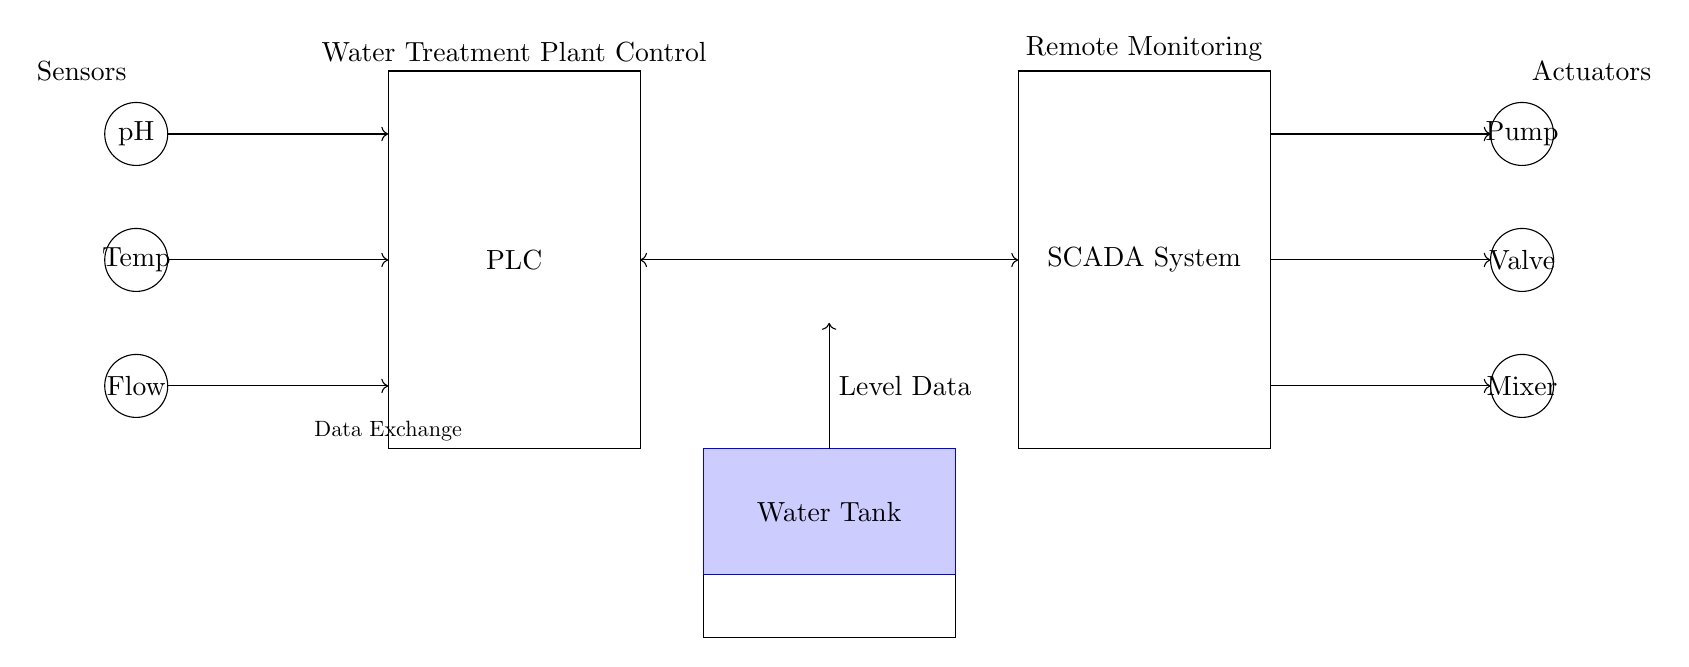What are the main components of the control system? The main components are the PLC, SCADA system, sensors (pH, temperature, flow), and actuators (pump, valve, mixer). These components are visually represented in the circuit diagram.
Answer: PLC, SCADA, Sensors, Actuators Which sensors are used in this water treatment control system? The diagram includes three sensors: pH, temperature, and flow. They are labeled and positioned on the left side of the circuit.
Answer: pH, temperature, flow What is the primary function of the PLC in this system? The PLC (Programmable Logic Controller) is responsible for processing the signal data from the sensors and controlling the output to the actuators accordingly. This makes it central to the control system's operations.
Answer: Control operations How is data exchanged between the PLC and the SCADA system? Data is exchanged through a bi-directional connection marked with a double arrow between the PLC and the SCADA system, indicating that data can flow both ways.
Answer: Bi-directional connection What types of actuators are present in the control system? The control system includes three types of actuators: a pump, a valve, and a mixer, which are indicated on the right side of the diagram. Each actuator performs a different function in the treatment process.
Answer: Pump, valve, mixer How does the water level data integrate into the system? The water tank, shown at the bottom of the diagram, is connected to the PLC with a one-way arrow indicating that the level data flows into the PLC, allowing it to monitor and adjust operations based on the water level.
Answer: Level data to PLC 